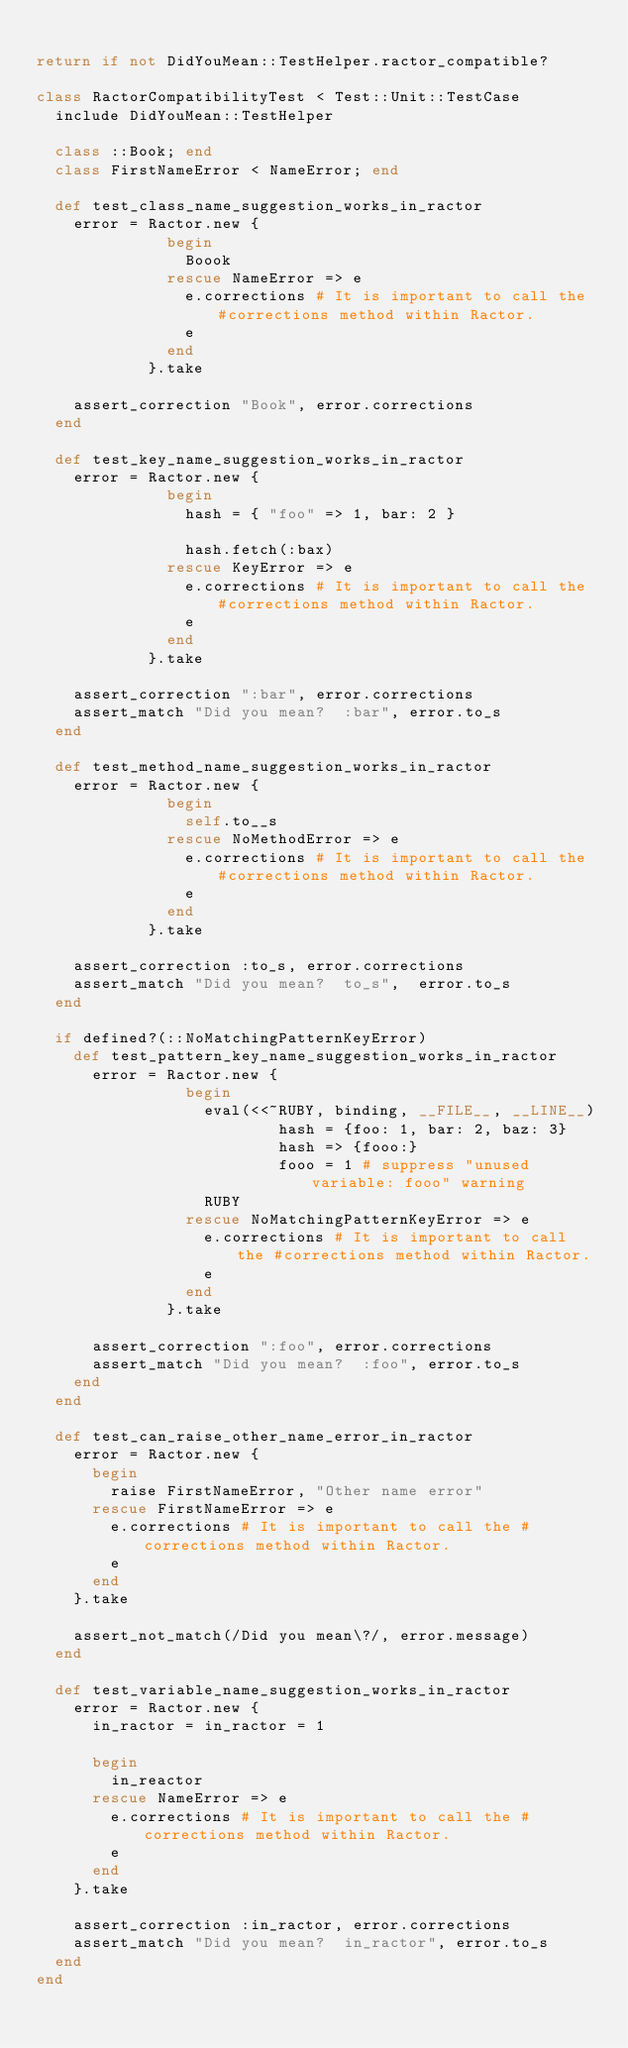<code> <loc_0><loc_0><loc_500><loc_500><_Ruby_>
return if not DidYouMean::TestHelper.ractor_compatible?

class RactorCompatibilityTest < Test::Unit::TestCase
  include DidYouMean::TestHelper

  class ::Book; end
  class FirstNameError < NameError; end

  def test_class_name_suggestion_works_in_ractor
    error = Ractor.new {
              begin
                Boook
              rescue NameError => e
                e.corrections # It is important to call the #corrections method within Ractor.
                e
              end
            }.take

    assert_correction "Book", error.corrections
  end

  def test_key_name_suggestion_works_in_ractor
    error = Ractor.new {
              begin
                hash = { "foo" => 1, bar: 2 }

                hash.fetch(:bax)
              rescue KeyError => e
                e.corrections # It is important to call the #corrections method within Ractor.
                e
              end
            }.take

    assert_correction ":bar", error.corrections
    assert_match "Did you mean?  :bar", error.to_s
  end

  def test_method_name_suggestion_works_in_ractor
    error = Ractor.new {
              begin
                self.to__s
              rescue NoMethodError => e
                e.corrections # It is important to call the #corrections method within Ractor.
                e
              end
            }.take

    assert_correction :to_s, error.corrections
    assert_match "Did you mean?  to_s",  error.to_s
  end

  if defined?(::NoMatchingPatternKeyError)
    def test_pattern_key_name_suggestion_works_in_ractor
      error = Ractor.new {
                begin
                  eval(<<~RUBY, binding, __FILE__, __LINE__)
                          hash = {foo: 1, bar: 2, baz: 3}
                          hash => {fooo:}
                          fooo = 1 # suppress "unused variable: fooo" warning
                  RUBY
                rescue NoMatchingPatternKeyError => e
                  e.corrections # It is important to call the #corrections method within Ractor.
                  e
                end
              }.take

      assert_correction ":foo", error.corrections
      assert_match "Did you mean?  :foo", error.to_s
    end
  end

  def test_can_raise_other_name_error_in_ractor
    error = Ractor.new {
      begin
        raise FirstNameError, "Other name error"
      rescue FirstNameError => e
        e.corrections # It is important to call the #corrections method within Ractor.
        e
      end
    }.take

    assert_not_match(/Did you mean\?/, error.message)
  end

  def test_variable_name_suggestion_works_in_ractor
    error = Ractor.new {
      in_ractor = in_ractor = 1

      begin
        in_reactor
      rescue NameError => e
        e.corrections # It is important to call the #corrections method within Ractor.
        e
      end
    }.take

    assert_correction :in_ractor, error.corrections
    assert_match "Did you mean?  in_ractor", error.to_s
  end
end
</code> 